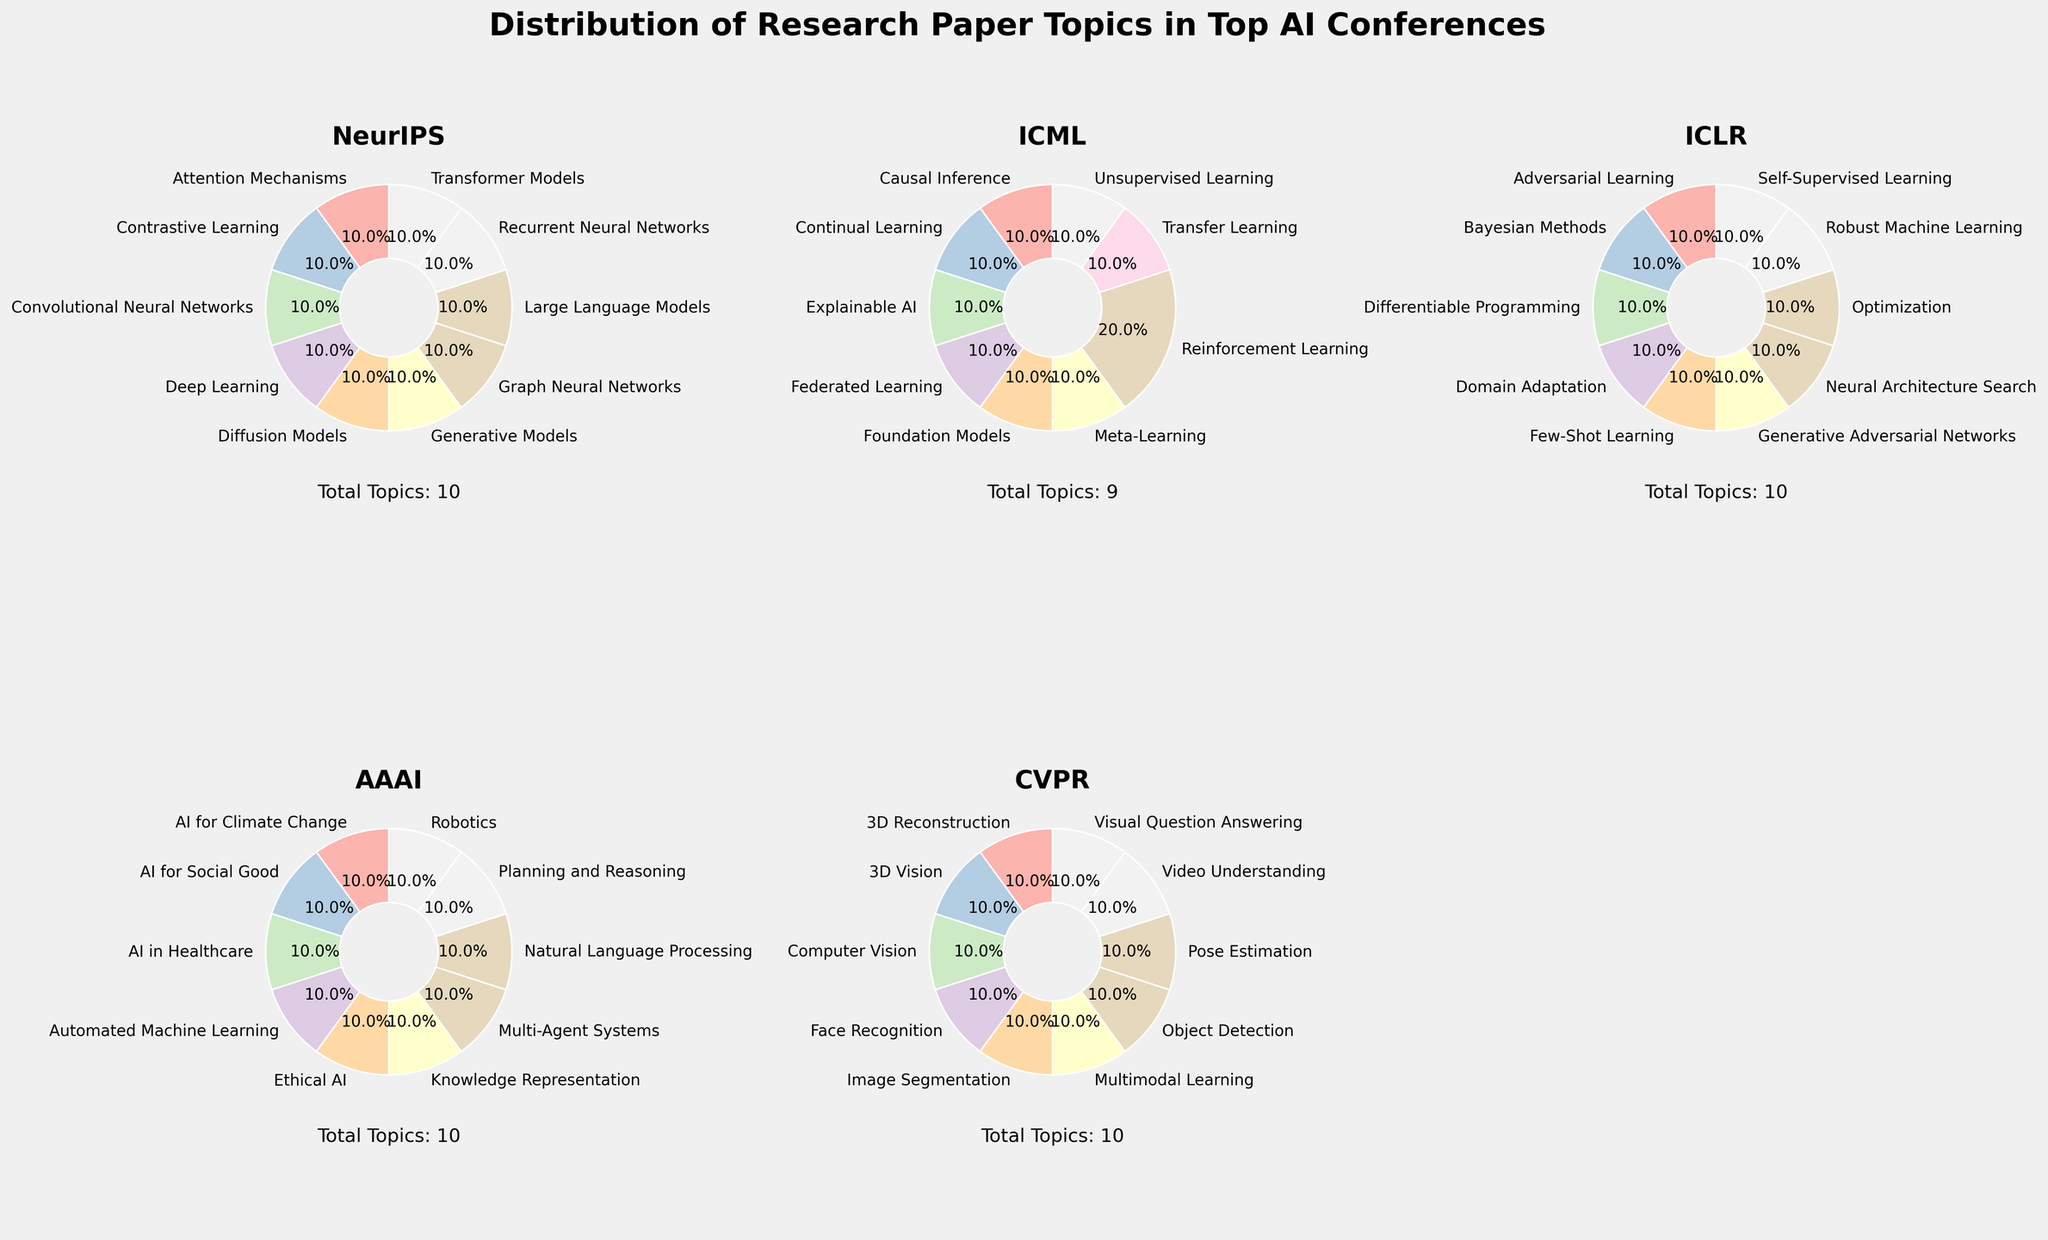What is the title of the figure? The title of the figure is the largest text at the top, centered and bold. The figure mentions "Distribution of Research Paper Topics in Top AI Conferences".
Answer: Distribution of Research Paper Topics in Top AI Conferences Which conference has the topic "Meta-Learning," and in what year did it appear? The conference titles are displayed on each subplot, and the topic labels on the pie charts indicate the topics for each year. Meta-Learning appears under ICML in the year 2016.
Answer: ICML, 2016 How many research topics are depicted in the AAAI subplot? Each pie chart displays multiple topic labels with percentages, and the total number of topics can be read by counting the segments in AAAI's pie chart. There are 10 research topics shown in the AAAI subplot's text annotation.
Answer: 10 Which conference's subplot uses the color closest to light green? Observing the colors used in the pie chart segments, ICML uses the color closest to light green (#4ECDC4).
Answer: ICML What is the most frequently appearing research topic in the NeurIPS conference over the years? By tallying the topics within the slices of NeurIPS pie charts, count how many times each topic appears. The most frequently appearing topic is Transformer Models.
Answer: Transformer Models Compare the frequency of "Adversarial Learning" topics between NeurIPS and ICLR. The pie charts show which topics are presented each year. Adversarial Learning appears once in NeurIPS (2015) and once in ICLR (2015). Thus, the frequency is the same.
Answer: Equal frequency Which conference included a focus on "Diffusion Models" and in what year? Look at each conference's pie chart to find where and when "Diffusion Models" appears. It is listed under NeurIPS for the year 2022.
Answer: NeurIPS, 2022 What percentage of ICML's topics in its subplot is contributed by "Reinforcement Learning"? Locate the ICML pie chart and the segment labeled "Reinforcement Learning", then note the percentage value. The "Reinforcement Learning" portion of the ICML pie chart represents 10% according to the data proportions.
Answer: 10% Which two years included topics related to "AI for Social Good," and under what conferences? By checking each pie chart for the label "AI for Social Good" and noting the conferences and years, it appears in AAAI (2020) and CVPR (2021).
Answer: AAAI (2020), CVPR (2021) Is the topic "Few-Shot Learning" more common in ICLR or CVPR? Compare the occurrence of "Few-Shot Learning" in the subplots for both conferences. It appears once in ICLR (2018) and does not appear in CVPR, making it more common in ICLR.
Answer: ICLR 